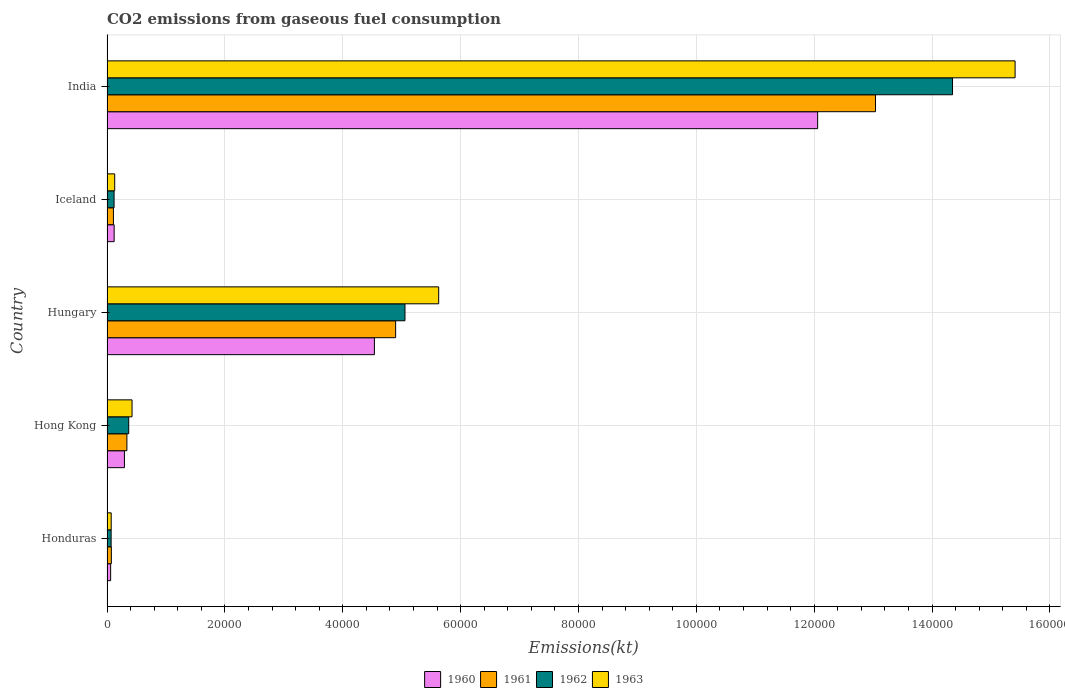How many different coloured bars are there?
Your response must be concise. 4. Are the number of bars per tick equal to the number of legend labels?
Make the answer very short. Yes. Are the number of bars on each tick of the Y-axis equal?
Your response must be concise. Yes. How many bars are there on the 5th tick from the top?
Give a very brief answer. 4. What is the label of the 5th group of bars from the top?
Provide a succinct answer. Honduras. In how many cases, is the number of bars for a given country not equal to the number of legend labels?
Your answer should be very brief. 0. What is the amount of CO2 emitted in 1962 in Iceland?
Keep it short and to the point. 1199.11. Across all countries, what is the maximum amount of CO2 emitted in 1960?
Your response must be concise. 1.21e+05. Across all countries, what is the minimum amount of CO2 emitted in 1963?
Ensure brevity in your answer.  711.4. In which country was the amount of CO2 emitted in 1963 maximum?
Ensure brevity in your answer.  India. In which country was the amount of CO2 emitted in 1960 minimum?
Provide a succinct answer. Honduras. What is the total amount of CO2 emitted in 1963 in the graph?
Keep it short and to the point. 2.17e+05. What is the difference between the amount of CO2 emitted in 1962 in Honduras and that in Hungary?
Your answer should be very brief. -4.99e+04. What is the difference between the amount of CO2 emitted in 1963 in Honduras and the amount of CO2 emitted in 1960 in Hong Kong?
Make the answer very short. -2244.2. What is the average amount of CO2 emitted in 1963 per country?
Make the answer very short. 4.33e+04. What is the difference between the amount of CO2 emitted in 1961 and amount of CO2 emitted in 1963 in India?
Offer a terse response. -2.37e+04. What is the ratio of the amount of CO2 emitted in 1960 in Hong Kong to that in India?
Make the answer very short. 0.02. Is the amount of CO2 emitted in 1960 in Honduras less than that in India?
Offer a terse response. Yes. Is the difference between the amount of CO2 emitted in 1961 in Hungary and Iceland greater than the difference between the amount of CO2 emitted in 1963 in Hungary and Iceland?
Give a very brief answer. No. What is the difference between the highest and the second highest amount of CO2 emitted in 1961?
Keep it short and to the point. 8.14e+04. What is the difference between the highest and the lowest amount of CO2 emitted in 1963?
Provide a short and direct response. 1.53e+05. Is the sum of the amount of CO2 emitted in 1960 in Iceland and India greater than the maximum amount of CO2 emitted in 1961 across all countries?
Make the answer very short. No. Is it the case that in every country, the sum of the amount of CO2 emitted in 1961 and amount of CO2 emitted in 1963 is greater than the sum of amount of CO2 emitted in 1960 and amount of CO2 emitted in 1962?
Give a very brief answer. No. What does the 4th bar from the bottom in Iceland represents?
Keep it short and to the point. 1963. Is it the case that in every country, the sum of the amount of CO2 emitted in 1960 and amount of CO2 emitted in 1963 is greater than the amount of CO2 emitted in 1962?
Provide a succinct answer. Yes. How many bars are there?
Offer a very short reply. 20. Are all the bars in the graph horizontal?
Offer a terse response. Yes. Are the values on the major ticks of X-axis written in scientific E-notation?
Ensure brevity in your answer.  No. Does the graph contain grids?
Offer a terse response. Yes. Where does the legend appear in the graph?
Your answer should be very brief. Bottom center. How are the legend labels stacked?
Provide a short and direct response. Horizontal. What is the title of the graph?
Your answer should be very brief. CO2 emissions from gaseous fuel consumption. Does "2004" appear as one of the legend labels in the graph?
Your answer should be compact. No. What is the label or title of the X-axis?
Give a very brief answer. Emissions(kt). What is the label or title of the Y-axis?
Your response must be concise. Country. What is the Emissions(kt) in 1960 in Honduras?
Your response must be concise. 616.06. What is the Emissions(kt) of 1961 in Honduras?
Your answer should be compact. 737.07. What is the Emissions(kt) in 1962 in Honduras?
Give a very brief answer. 700.4. What is the Emissions(kt) of 1963 in Honduras?
Your response must be concise. 711.4. What is the Emissions(kt) in 1960 in Hong Kong?
Make the answer very short. 2955.6. What is the Emissions(kt) of 1961 in Hong Kong?
Your response must be concise. 3373.64. What is the Emissions(kt) in 1962 in Hong Kong?
Offer a very short reply. 3685.34. What is the Emissions(kt) in 1963 in Hong Kong?
Provide a short and direct response. 4250.05. What is the Emissions(kt) in 1960 in Hungary?
Keep it short and to the point. 4.54e+04. What is the Emissions(kt) in 1961 in Hungary?
Offer a very short reply. 4.90e+04. What is the Emissions(kt) in 1962 in Hungary?
Make the answer very short. 5.06e+04. What is the Emissions(kt) of 1963 in Hungary?
Offer a terse response. 5.63e+04. What is the Emissions(kt) of 1960 in Iceland?
Your answer should be compact. 1213.78. What is the Emissions(kt) in 1961 in Iceland?
Offer a very short reply. 1092.77. What is the Emissions(kt) in 1962 in Iceland?
Provide a succinct answer. 1199.11. What is the Emissions(kt) in 1963 in Iceland?
Provide a succinct answer. 1305.45. What is the Emissions(kt) of 1960 in India?
Offer a terse response. 1.21e+05. What is the Emissions(kt) in 1961 in India?
Your answer should be compact. 1.30e+05. What is the Emissions(kt) in 1962 in India?
Keep it short and to the point. 1.43e+05. What is the Emissions(kt) of 1963 in India?
Offer a very short reply. 1.54e+05. Across all countries, what is the maximum Emissions(kt) of 1960?
Your answer should be compact. 1.21e+05. Across all countries, what is the maximum Emissions(kt) in 1961?
Offer a terse response. 1.30e+05. Across all countries, what is the maximum Emissions(kt) of 1962?
Your answer should be compact. 1.43e+05. Across all countries, what is the maximum Emissions(kt) of 1963?
Your answer should be compact. 1.54e+05. Across all countries, what is the minimum Emissions(kt) in 1960?
Keep it short and to the point. 616.06. Across all countries, what is the minimum Emissions(kt) in 1961?
Offer a very short reply. 737.07. Across all countries, what is the minimum Emissions(kt) of 1962?
Make the answer very short. 700.4. Across all countries, what is the minimum Emissions(kt) of 1963?
Offer a very short reply. 711.4. What is the total Emissions(kt) in 1960 in the graph?
Provide a succinct answer. 1.71e+05. What is the total Emissions(kt) in 1961 in the graph?
Make the answer very short. 1.85e+05. What is the total Emissions(kt) in 1962 in the graph?
Ensure brevity in your answer.  2.00e+05. What is the total Emissions(kt) of 1963 in the graph?
Ensure brevity in your answer.  2.17e+05. What is the difference between the Emissions(kt) of 1960 in Honduras and that in Hong Kong?
Provide a succinct answer. -2339.55. What is the difference between the Emissions(kt) of 1961 in Honduras and that in Hong Kong?
Provide a succinct answer. -2636.57. What is the difference between the Emissions(kt) of 1962 in Honduras and that in Hong Kong?
Provide a succinct answer. -2984.94. What is the difference between the Emissions(kt) in 1963 in Honduras and that in Hong Kong?
Offer a terse response. -3538.66. What is the difference between the Emissions(kt) of 1960 in Honduras and that in Hungary?
Your answer should be very brief. -4.48e+04. What is the difference between the Emissions(kt) in 1961 in Honduras and that in Hungary?
Your response must be concise. -4.82e+04. What is the difference between the Emissions(kt) in 1962 in Honduras and that in Hungary?
Keep it short and to the point. -4.99e+04. What is the difference between the Emissions(kt) of 1963 in Honduras and that in Hungary?
Offer a terse response. -5.56e+04. What is the difference between the Emissions(kt) in 1960 in Honduras and that in Iceland?
Make the answer very short. -597.72. What is the difference between the Emissions(kt) of 1961 in Honduras and that in Iceland?
Keep it short and to the point. -355.7. What is the difference between the Emissions(kt) of 1962 in Honduras and that in Iceland?
Provide a short and direct response. -498.71. What is the difference between the Emissions(kt) in 1963 in Honduras and that in Iceland?
Offer a terse response. -594.05. What is the difference between the Emissions(kt) in 1960 in Honduras and that in India?
Offer a terse response. -1.20e+05. What is the difference between the Emissions(kt) of 1961 in Honduras and that in India?
Keep it short and to the point. -1.30e+05. What is the difference between the Emissions(kt) of 1962 in Honduras and that in India?
Provide a short and direct response. -1.43e+05. What is the difference between the Emissions(kt) of 1963 in Honduras and that in India?
Ensure brevity in your answer.  -1.53e+05. What is the difference between the Emissions(kt) of 1960 in Hong Kong and that in Hungary?
Your response must be concise. -4.24e+04. What is the difference between the Emissions(kt) of 1961 in Hong Kong and that in Hungary?
Offer a terse response. -4.56e+04. What is the difference between the Emissions(kt) of 1962 in Hong Kong and that in Hungary?
Make the answer very short. -4.69e+04. What is the difference between the Emissions(kt) in 1963 in Hong Kong and that in Hungary?
Your answer should be very brief. -5.20e+04. What is the difference between the Emissions(kt) in 1960 in Hong Kong and that in Iceland?
Your answer should be compact. 1741.83. What is the difference between the Emissions(kt) in 1961 in Hong Kong and that in Iceland?
Your answer should be very brief. 2280.87. What is the difference between the Emissions(kt) of 1962 in Hong Kong and that in Iceland?
Make the answer very short. 2486.23. What is the difference between the Emissions(kt) of 1963 in Hong Kong and that in Iceland?
Your answer should be very brief. 2944.6. What is the difference between the Emissions(kt) of 1960 in Hong Kong and that in India?
Keep it short and to the point. -1.18e+05. What is the difference between the Emissions(kt) in 1961 in Hong Kong and that in India?
Ensure brevity in your answer.  -1.27e+05. What is the difference between the Emissions(kt) of 1962 in Hong Kong and that in India?
Your answer should be very brief. -1.40e+05. What is the difference between the Emissions(kt) in 1963 in Hong Kong and that in India?
Offer a very short reply. -1.50e+05. What is the difference between the Emissions(kt) in 1960 in Hungary and that in Iceland?
Ensure brevity in your answer.  4.42e+04. What is the difference between the Emissions(kt) of 1961 in Hungary and that in Iceland?
Give a very brief answer. 4.79e+04. What is the difference between the Emissions(kt) in 1962 in Hungary and that in Iceland?
Make the answer very short. 4.94e+04. What is the difference between the Emissions(kt) in 1963 in Hungary and that in Iceland?
Your answer should be very brief. 5.50e+04. What is the difference between the Emissions(kt) of 1960 in Hungary and that in India?
Provide a succinct answer. -7.52e+04. What is the difference between the Emissions(kt) of 1961 in Hungary and that in India?
Offer a terse response. -8.14e+04. What is the difference between the Emissions(kt) of 1962 in Hungary and that in India?
Ensure brevity in your answer.  -9.29e+04. What is the difference between the Emissions(kt) of 1963 in Hungary and that in India?
Ensure brevity in your answer.  -9.78e+04. What is the difference between the Emissions(kt) of 1960 in Iceland and that in India?
Provide a succinct answer. -1.19e+05. What is the difference between the Emissions(kt) in 1961 in Iceland and that in India?
Offer a very short reply. -1.29e+05. What is the difference between the Emissions(kt) in 1962 in Iceland and that in India?
Your response must be concise. -1.42e+05. What is the difference between the Emissions(kt) in 1963 in Iceland and that in India?
Ensure brevity in your answer.  -1.53e+05. What is the difference between the Emissions(kt) in 1960 in Honduras and the Emissions(kt) in 1961 in Hong Kong?
Keep it short and to the point. -2757.58. What is the difference between the Emissions(kt) of 1960 in Honduras and the Emissions(kt) of 1962 in Hong Kong?
Keep it short and to the point. -3069.28. What is the difference between the Emissions(kt) in 1960 in Honduras and the Emissions(kt) in 1963 in Hong Kong?
Ensure brevity in your answer.  -3634. What is the difference between the Emissions(kt) of 1961 in Honduras and the Emissions(kt) of 1962 in Hong Kong?
Offer a very short reply. -2948.27. What is the difference between the Emissions(kt) of 1961 in Honduras and the Emissions(kt) of 1963 in Hong Kong?
Offer a terse response. -3512.99. What is the difference between the Emissions(kt) in 1962 in Honduras and the Emissions(kt) in 1963 in Hong Kong?
Offer a terse response. -3549.66. What is the difference between the Emissions(kt) in 1960 in Honduras and the Emissions(kt) in 1961 in Hungary?
Ensure brevity in your answer.  -4.84e+04. What is the difference between the Emissions(kt) in 1960 in Honduras and the Emissions(kt) in 1962 in Hungary?
Your answer should be very brief. -4.99e+04. What is the difference between the Emissions(kt) of 1960 in Honduras and the Emissions(kt) of 1963 in Hungary?
Keep it short and to the point. -5.57e+04. What is the difference between the Emissions(kt) in 1961 in Honduras and the Emissions(kt) in 1962 in Hungary?
Ensure brevity in your answer.  -4.98e+04. What is the difference between the Emissions(kt) of 1961 in Honduras and the Emissions(kt) of 1963 in Hungary?
Make the answer very short. -5.55e+04. What is the difference between the Emissions(kt) in 1962 in Honduras and the Emissions(kt) in 1963 in Hungary?
Offer a terse response. -5.56e+04. What is the difference between the Emissions(kt) in 1960 in Honduras and the Emissions(kt) in 1961 in Iceland?
Ensure brevity in your answer.  -476.71. What is the difference between the Emissions(kt) of 1960 in Honduras and the Emissions(kt) of 1962 in Iceland?
Your response must be concise. -583.05. What is the difference between the Emissions(kt) in 1960 in Honduras and the Emissions(kt) in 1963 in Iceland?
Ensure brevity in your answer.  -689.4. What is the difference between the Emissions(kt) of 1961 in Honduras and the Emissions(kt) of 1962 in Iceland?
Offer a very short reply. -462.04. What is the difference between the Emissions(kt) of 1961 in Honduras and the Emissions(kt) of 1963 in Iceland?
Provide a short and direct response. -568.38. What is the difference between the Emissions(kt) of 1962 in Honduras and the Emissions(kt) of 1963 in Iceland?
Keep it short and to the point. -605.05. What is the difference between the Emissions(kt) of 1960 in Honduras and the Emissions(kt) of 1961 in India?
Provide a succinct answer. -1.30e+05. What is the difference between the Emissions(kt) in 1960 in Honduras and the Emissions(kt) in 1962 in India?
Provide a short and direct response. -1.43e+05. What is the difference between the Emissions(kt) of 1960 in Honduras and the Emissions(kt) of 1963 in India?
Offer a very short reply. -1.53e+05. What is the difference between the Emissions(kt) in 1961 in Honduras and the Emissions(kt) in 1962 in India?
Give a very brief answer. -1.43e+05. What is the difference between the Emissions(kt) in 1961 in Honduras and the Emissions(kt) in 1963 in India?
Give a very brief answer. -1.53e+05. What is the difference between the Emissions(kt) of 1962 in Honduras and the Emissions(kt) of 1963 in India?
Offer a very short reply. -1.53e+05. What is the difference between the Emissions(kt) in 1960 in Hong Kong and the Emissions(kt) in 1961 in Hungary?
Provide a succinct answer. -4.60e+04. What is the difference between the Emissions(kt) in 1960 in Hong Kong and the Emissions(kt) in 1962 in Hungary?
Your answer should be compact. -4.76e+04. What is the difference between the Emissions(kt) in 1960 in Hong Kong and the Emissions(kt) in 1963 in Hungary?
Keep it short and to the point. -5.33e+04. What is the difference between the Emissions(kt) in 1961 in Hong Kong and the Emissions(kt) in 1962 in Hungary?
Your answer should be very brief. -4.72e+04. What is the difference between the Emissions(kt) in 1961 in Hong Kong and the Emissions(kt) in 1963 in Hungary?
Provide a succinct answer. -5.29e+04. What is the difference between the Emissions(kt) in 1962 in Hong Kong and the Emissions(kt) in 1963 in Hungary?
Ensure brevity in your answer.  -5.26e+04. What is the difference between the Emissions(kt) of 1960 in Hong Kong and the Emissions(kt) of 1961 in Iceland?
Offer a terse response. 1862.84. What is the difference between the Emissions(kt) in 1960 in Hong Kong and the Emissions(kt) in 1962 in Iceland?
Keep it short and to the point. 1756.49. What is the difference between the Emissions(kt) of 1960 in Hong Kong and the Emissions(kt) of 1963 in Iceland?
Make the answer very short. 1650.15. What is the difference between the Emissions(kt) of 1961 in Hong Kong and the Emissions(kt) of 1962 in Iceland?
Provide a succinct answer. 2174.53. What is the difference between the Emissions(kt) of 1961 in Hong Kong and the Emissions(kt) of 1963 in Iceland?
Provide a succinct answer. 2068.19. What is the difference between the Emissions(kt) in 1962 in Hong Kong and the Emissions(kt) in 1963 in Iceland?
Ensure brevity in your answer.  2379.88. What is the difference between the Emissions(kt) of 1960 in Hong Kong and the Emissions(kt) of 1961 in India?
Give a very brief answer. -1.27e+05. What is the difference between the Emissions(kt) of 1960 in Hong Kong and the Emissions(kt) of 1962 in India?
Keep it short and to the point. -1.41e+05. What is the difference between the Emissions(kt) in 1960 in Hong Kong and the Emissions(kt) in 1963 in India?
Your response must be concise. -1.51e+05. What is the difference between the Emissions(kt) of 1961 in Hong Kong and the Emissions(kt) of 1962 in India?
Give a very brief answer. -1.40e+05. What is the difference between the Emissions(kt) in 1961 in Hong Kong and the Emissions(kt) in 1963 in India?
Give a very brief answer. -1.51e+05. What is the difference between the Emissions(kt) in 1962 in Hong Kong and the Emissions(kt) in 1963 in India?
Offer a terse response. -1.50e+05. What is the difference between the Emissions(kt) of 1960 in Hungary and the Emissions(kt) of 1961 in Iceland?
Provide a succinct answer. 4.43e+04. What is the difference between the Emissions(kt) of 1960 in Hungary and the Emissions(kt) of 1962 in Iceland?
Offer a very short reply. 4.42e+04. What is the difference between the Emissions(kt) in 1960 in Hungary and the Emissions(kt) in 1963 in Iceland?
Offer a terse response. 4.41e+04. What is the difference between the Emissions(kt) in 1961 in Hungary and the Emissions(kt) in 1962 in Iceland?
Give a very brief answer. 4.78e+04. What is the difference between the Emissions(kt) of 1961 in Hungary and the Emissions(kt) of 1963 in Iceland?
Ensure brevity in your answer.  4.77e+04. What is the difference between the Emissions(kt) of 1962 in Hungary and the Emissions(kt) of 1963 in Iceland?
Your response must be concise. 4.93e+04. What is the difference between the Emissions(kt) in 1960 in Hungary and the Emissions(kt) in 1961 in India?
Provide a succinct answer. -8.50e+04. What is the difference between the Emissions(kt) in 1960 in Hungary and the Emissions(kt) in 1962 in India?
Give a very brief answer. -9.81e+04. What is the difference between the Emissions(kt) of 1960 in Hungary and the Emissions(kt) of 1963 in India?
Your answer should be compact. -1.09e+05. What is the difference between the Emissions(kt) of 1961 in Hungary and the Emissions(kt) of 1962 in India?
Provide a succinct answer. -9.45e+04. What is the difference between the Emissions(kt) of 1961 in Hungary and the Emissions(kt) of 1963 in India?
Keep it short and to the point. -1.05e+05. What is the difference between the Emissions(kt) of 1962 in Hungary and the Emissions(kt) of 1963 in India?
Your answer should be very brief. -1.04e+05. What is the difference between the Emissions(kt) of 1960 in Iceland and the Emissions(kt) of 1961 in India?
Ensure brevity in your answer.  -1.29e+05. What is the difference between the Emissions(kt) of 1960 in Iceland and the Emissions(kt) of 1962 in India?
Provide a short and direct response. -1.42e+05. What is the difference between the Emissions(kt) in 1960 in Iceland and the Emissions(kt) in 1963 in India?
Keep it short and to the point. -1.53e+05. What is the difference between the Emissions(kt) in 1961 in Iceland and the Emissions(kt) in 1962 in India?
Make the answer very short. -1.42e+05. What is the difference between the Emissions(kt) in 1961 in Iceland and the Emissions(kt) in 1963 in India?
Give a very brief answer. -1.53e+05. What is the difference between the Emissions(kt) of 1962 in Iceland and the Emissions(kt) of 1963 in India?
Provide a succinct answer. -1.53e+05. What is the average Emissions(kt) in 1960 per country?
Your answer should be compact. 3.41e+04. What is the average Emissions(kt) in 1961 per country?
Keep it short and to the point. 3.69e+04. What is the average Emissions(kt) in 1962 per country?
Provide a short and direct response. 3.99e+04. What is the average Emissions(kt) of 1963 per country?
Keep it short and to the point. 4.33e+04. What is the difference between the Emissions(kt) of 1960 and Emissions(kt) of 1961 in Honduras?
Offer a terse response. -121.01. What is the difference between the Emissions(kt) in 1960 and Emissions(kt) in 1962 in Honduras?
Give a very brief answer. -84.34. What is the difference between the Emissions(kt) of 1960 and Emissions(kt) of 1963 in Honduras?
Offer a terse response. -95.34. What is the difference between the Emissions(kt) of 1961 and Emissions(kt) of 1962 in Honduras?
Make the answer very short. 36.67. What is the difference between the Emissions(kt) of 1961 and Emissions(kt) of 1963 in Honduras?
Your response must be concise. 25.67. What is the difference between the Emissions(kt) of 1962 and Emissions(kt) of 1963 in Honduras?
Provide a succinct answer. -11. What is the difference between the Emissions(kt) of 1960 and Emissions(kt) of 1961 in Hong Kong?
Keep it short and to the point. -418.04. What is the difference between the Emissions(kt) in 1960 and Emissions(kt) in 1962 in Hong Kong?
Your response must be concise. -729.73. What is the difference between the Emissions(kt) in 1960 and Emissions(kt) in 1963 in Hong Kong?
Provide a short and direct response. -1294.45. What is the difference between the Emissions(kt) in 1961 and Emissions(kt) in 1962 in Hong Kong?
Provide a succinct answer. -311.69. What is the difference between the Emissions(kt) of 1961 and Emissions(kt) of 1963 in Hong Kong?
Provide a short and direct response. -876.41. What is the difference between the Emissions(kt) of 1962 and Emissions(kt) of 1963 in Hong Kong?
Your answer should be very brief. -564.72. What is the difference between the Emissions(kt) of 1960 and Emissions(kt) of 1961 in Hungary?
Your response must be concise. -3604.66. What is the difference between the Emissions(kt) in 1960 and Emissions(kt) in 1962 in Hungary?
Offer a terse response. -5188.81. What is the difference between the Emissions(kt) in 1960 and Emissions(kt) in 1963 in Hungary?
Your response must be concise. -1.09e+04. What is the difference between the Emissions(kt) of 1961 and Emissions(kt) of 1962 in Hungary?
Give a very brief answer. -1584.14. What is the difference between the Emissions(kt) of 1961 and Emissions(kt) of 1963 in Hungary?
Ensure brevity in your answer.  -7304.66. What is the difference between the Emissions(kt) in 1962 and Emissions(kt) in 1963 in Hungary?
Provide a short and direct response. -5720.52. What is the difference between the Emissions(kt) in 1960 and Emissions(kt) in 1961 in Iceland?
Ensure brevity in your answer.  121.01. What is the difference between the Emissions(kt) in 1960 and Emissions(kt) in 1962 in Iceland?
Make the answer very short. 14.67. What is the difference between the Emissions(kt) of 1960 and Emissions(kt) of 1963 in Iceland?
Make the answer very short. -91.67. What is the difference between the Emissions(kt) of 1961 and Emissions(kt) of 1962 in Iceland?
Make the answer very short. -106.34. What is the difference between the Emissions(kt) of 1961 and Emissions(kt) of 1963 in Iceland?
Provide a succinct answer. -212.69. What is the difference between the Emissions(kt) of 1962 and Emissions(kt) of 1963 in Iceland?
Your response must be concise. -106.34. What is the difference between the Emissions(kt) of 1960 and Emissions(kt) of 1961 in India?
Your response must be concise. -9820.23. What is the difference between the Emissions(kt) in 1960 and Emissions(kt) in 1962 in India?
Your answer should be very brief. -2.29e+04. What is the difference between the Emissions(kt) in 1960 and Emissions(kt) in 1963 in India?
Your answer should be compact. -3.35e+04. What is the difference between the Emissions(kt) of 1961 and Emissions(kt) of 1962 in India?
Offer a terse response. -1.31e+04. What is the difference between the Emissions(kt) of 1961 and Emissions(kt) of 1963 in India?
Provide a short and direct response. -2.37e+04. What is the difference between the Emissions(kt) of 1962 and Emissions(kt) of 1963 in India?
Ensure brevity in your answer.  -1.06e+04. What is the ratio of the Emissions(kt) of 1960 in Honduras to that in Hong Kong?
Provide a succinct answer. 0.21. What is the ratio of the Emissions(kt) in 1961 in Honduras to that in Hong Kong?
Ensure brevity in your answer.  0.22. What is the ratio of the Emissions(kt) in 1962 in Honduras to that in Hong Kong?
Provide a succinct answer. 0.19. What is the ratio of the Emissions(kt) in 1963 in Honduras to that in Hong Kong?
Give a very brief answer. 0.17. What is the ratio of the Emissions(kt) in 1960 in Honduras to that in Hungary?
Your response must be concise. 0.01. What is the ratio of the Emissions(kt) in 1961 in Honduras to that in Hungary?
Offer a terse response. 0.01. What is the ratio of the Emissions(kt) of 1962 in Honduras to that in Hungary?
Your response must be concise. 0.01. What is the ratio of the Emissions(kt) in 1963 in Honduras to that in Hungary?
Make the answer very short. 0.01. What is the ratio of the Emissions(kt) of 1960 in Honduras to that in Iceland?
Provide a succinct answer. 0.51. What is the ratio of the Emissions(kt) of 1961 in Honduras to that in Iceland?
Give a very brief answer. 0.67. What is the ratio of the Emissions(kt) of 1962 in Honduras to that in Iceland?
Ensure brevity in your answer.  0.58. What is the ratio of the Emissions(kt) in 1963 in Honduras to that in Iceland?
Provide a succinct answer. 0.54. What is the ratio of the Emissions(kt) in 1960 in Honduras to that in India?
Your answer should be compact. 0.01. What is the ratio of the Emissions(kt) in 1961 in Honduras to that in India?
Offer a terse response. 0.01. What is the ratio of the Emissions(kt) in 1962 in Honduras to that in India?
Provide a short and direct response. 0. What is the ratio of the Emissions(kt) of 1963 in Honduras to that in India?
Offer a very short reply. 0. What is the ratio of the Emissions(kt) of 1960 in Hong Kong to that in Hungary?
Offer a very short reply. 0.07. What is the ratio of the Emissions(kt) of 1961 in Hong Kong to that in Hungary?
Your response must be concise. 0.07. What is the ratio of the Emissions(kt) in 1962 in Hong Kong to that in Hungary?
Your response must be concise. 0.07. What is the ratio of the Emissions(kt) in 1963 in Hong Kong to that in Hungary?
Ensure brevity in your answer.  0.08. What is the ratio of the Emissions(kt) in 1960 in Hong Kong to that in Iceland?
Offer a very short reply. 2.44. What is the ratio of the Emissions(kt) in 1961 in Hong Kong to that in Iceland?
Give a very brief answer. 3.09. What is the ratio of the Emissions(kt) in 1962 in Hong Kong to that in Iceland?
Provide a succinct answer. 3.07. What is the ratio of the Emissions(kt) in 1963 in Hong Kong to that in Iceland?
Make the answer very short. 3.26. What is the ratio of the Emissions(kt) in 1960 in Hong Kong to that in India?
Make the answer very short. 0.02. What is the ratio of the Emissions(kt) in 1961 in Hong Kong to that in India?
Your response must be concise. 0.03. What is the ratio of the Emissions(kt) in 1962 in Hong Kong to that in India?
Give a very brief answer. 0.03. What is the ratio of the Emissions(kt) in 1963 in Hong Kong to that in India?
Give a very brief answer. 0.03. What is the ratio of the Emissions(kt) of 1960 in Hungary to that in Iceland?
Ensure brevity in your answer.  37.38. What is the ratio of the Emissions(kt) in 1961 in Hungary to that in Iceland?
Give a very brief answer. 44.82. What is the ratio of the Emissions(kt) of 1962 in Hungary to that in Iceland?
Provide a short and direct response. 42.17. What is the ratio of the Emissions(kt) of 1963 in Hungary to that in Iceland?
Provide a short and direct response. 43.11. What is the ratio of the Emissions(kt) of 1960 in Hungary to that in India?
Keep it short and to the point. 0.38. What is the ratio of the Emissions(kt) in 1961 in Hungary to that in India?
Keep it short and to the point. 0.38. What is the ratio of the Emissions(kt) in 1962 in Hungary to that in India?
Make the answer very short. 0.35. What is the ratio of the Emissions(kt) in 1963 in Hungary to that in India?
Make the answer very short. 0.37. What is the ratio of the Emissions(kt) in 1960 in Iceland to that in India?
Your answer should be very brief. 0.01. What is the ratio of the Emissions(kt) in 1961 in Iceland to that in India?
Your answer should be compact. 0.01. What is the ratio of the Emissions(kt) of 1962 in Iceland to that in India?
Provide a short and direct response. 0.01. What is the ratio of the Emissions(kt) in 1963 in Iceland to that in India?
Make the answer very short. 0.01. What is the difference between the highest and the second highest Emissions(kt) in 1960?
Offer a very short reply. 7.52e+04. What is the difference between the highest and the second highest Emissions(kt) of 1961?
Your response must be concise. 8.14e+04. What is the difference between the highest and the second highest Emissions(kt) of 1962?
Provide a succinct answer. 9.29e+04. What is the difference between the highest and the second highest Emissions(kt) in 1963?
Offer a very short reply. 9.78e+04. What is the difference between the highest and the lowest Emissions(kt) in 1960?
Provide a succinct answer. 1.20e+05. What is the difference between the highest and the lowest Emissions(kt) in 1961?
Give a very brief answer. 1.30e+05. What is the difference between the highest and the lowest Emissions(kt) of 1962?
Provide a succinct answer. 1.43e+05. What is the difference between the highest and the lowest Emissions(kt) in 1963?
Provide a succinct answer. 1.53e+05. 